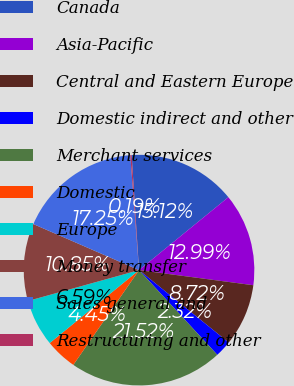<chart> <loc_0><loc_0><loc_500><loc_500><pie_chart><fcel>Canada<fcel>Asia-Pacific<fcel>Central and Eastern Europe<fcel>Domestic indirect and other<fcel>Merchant services<fcel>Domestic<fcel>Europe<fcel>Money transfer<fcel>Sales general and<fcel>Restructuring and other<nl><fcel>15.12%<fcel>12.99%<fcel>8.72%<fcel>2.32%<fcel>21.52%<fcel>4.45%<fcel>6.59%<fcel>10.85%<fcel>17.25%<fcel>0.19%<nl></chart> 